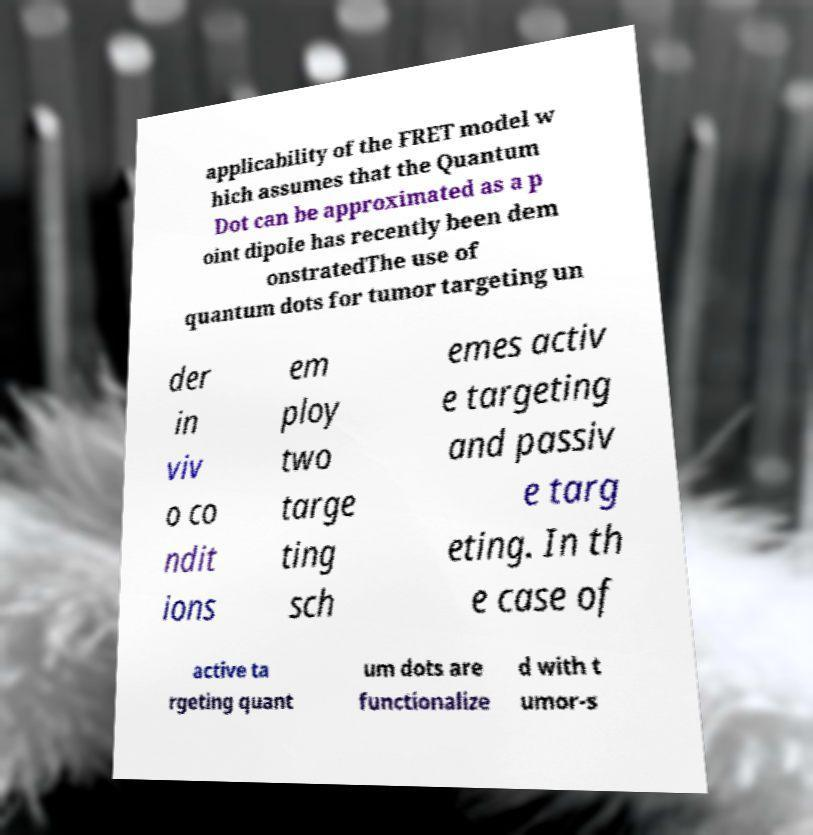There's text embedded in this image that I need extracted. Can you transcribe it verbatim? applicability of the FRET model w hich assumes that the Quantum Dot can be approximated as a p oint dipole has recently been dem onstratedThe use of quantum dots for tumor targeting un der in viv o co ndit ions em ploy two targe ting sch emes activ e targeting and passiv e targ eting. In th e case of active ta rgeting quant um dots are functionalize d with t umor-s 